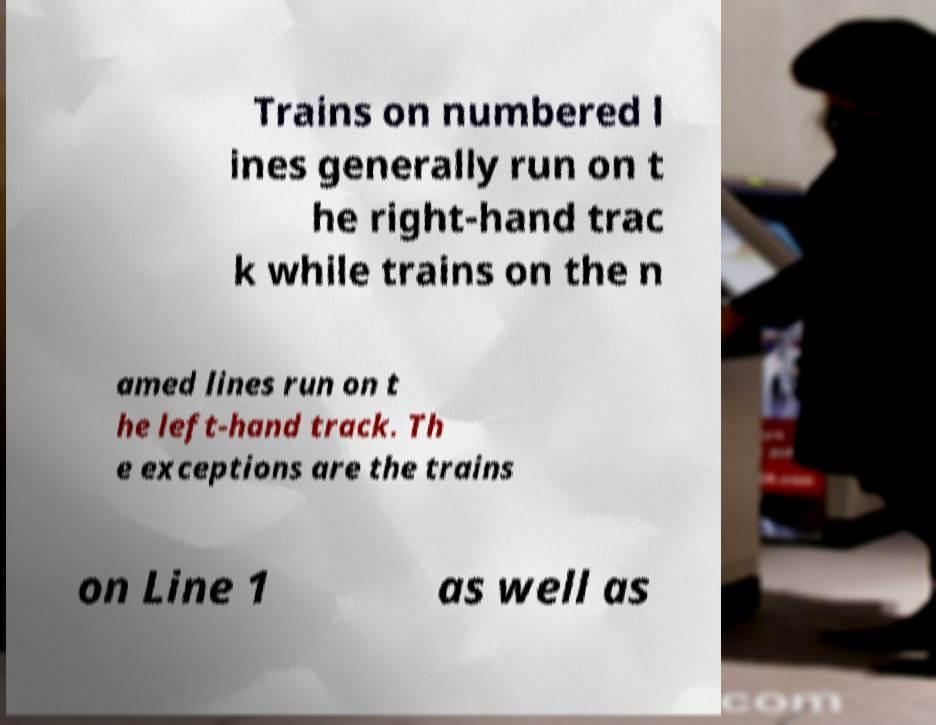Could you assist in decoding the text presented in this image and type it out clearly? Trains on numbered l ines generally run on t he right-hand trac k while trains on the n amed lines run on t he left-hand track. Th e exceptions are the trains on Line 1 as well as 